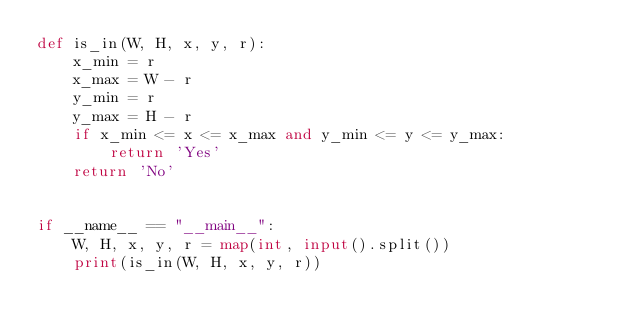<code> <loc_0><loc_0><loc_500><loc_500><_Python_>def is_in(W, H, x, y, r):
    x_min = r
    x_max = W - r
    y_min = r
    y_max = H - r
    if x_min <= x <= x_max and y_min <= y <= y_max:
        return 'Yes'
    return 'No'


if __name__ == "__main__":
    W, H, x, y, r = map(int, input().split())
    print(is_in(W, H, x, y, r))

</code> 